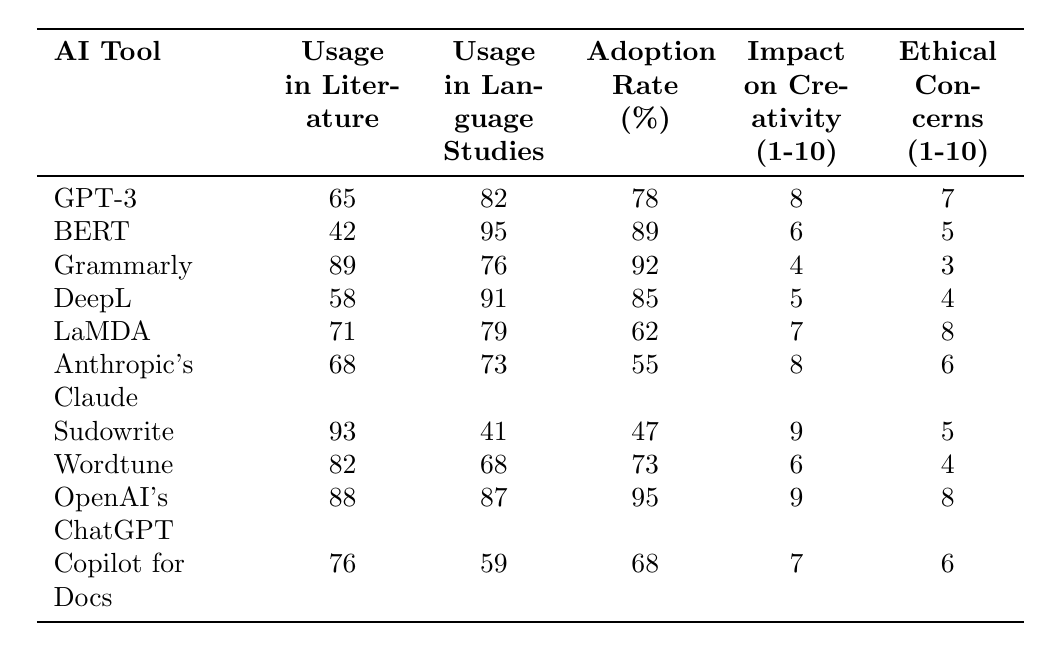What is the adoption rate of Grammarly? According to the table, Grammarly has an adoption rate of 92%.
Answer: 92% Which AI tool has the highest usage in literature? The table shows that Sudowrite has the highest usage in literature at 93%.
Answer: Sudowrite What is the ethical concerns rating of LaMDA? The table lists the ethical concerns rating for LaMDA as 8.
Answer: 8 What is the average impact on creativity of all the AI tools listed? To calculate the average, add all the impact values: 8 + 6 + 4 + 5 + 7 + 8 + 9 + 6 + 9 + 7 = 69. Then, divide by the number of AI tools (10), which gives 69/10 = 6.9.
Answer: 6.9 What is the difference in usage between BERT in language studies and Sudowrite in language studies? From the table, BERT's usage in language studies is 95%, and Sudowrite's is 41%. The difference is 95 - 41 = 54%.
Answer: 54% Do more AI tools have a higher usage in language studies than in literature? By counting, 6 tools have higher usage in language studies (BERT, Grammarly, DeepL, LaMDA, OpenAI's ChatGPT, and Anthropic's Claude) compared to 4 tools in literature (Sudowrite and Grammarly). Therefore, yes, more tools have higher usage in language studies.
Answer: Yes Which AI tool has a higher impact on creativity, GPT-3 or DeepL? The impact on creativity for GPT-3 is 8 and for DeepL is 5. Comparing these, GPT-3 has a higher impact on creativity at 8.
Answer: GPT-3 What percentage of usage in language studies is attributed to Wordtune? The table indicates that Wordtune has a usage in language studies of 68%.
Answer: 68% Is there an AI tool that has a lower impact on creativity than DeepL? Reviewing the table, both Grammarly (4) and Sudowrite (9) have lower impacts than DeepL's 5. Therefore, yes, there are AI tools with lower creativity impacts than DeepL.
Answer: Yes What is the average adoption rate of AI tools used in both literature and language studies? The adoption rates are 78, 89, 92, 85, 62, 55, 47, 73, 95, and 68. Summing these gives 78 + 89 + 92 + 85 + 62 + 55 + 47 + 73 + 95 + 68 = 90. The average is then calculated as 90/10 = 78.
Answer: 78 Which AI tool has the lowest ethical concerns rating? According to the table, Grammarly has the lowest ethical concerns rating at 3.
Answer: Grammarly 